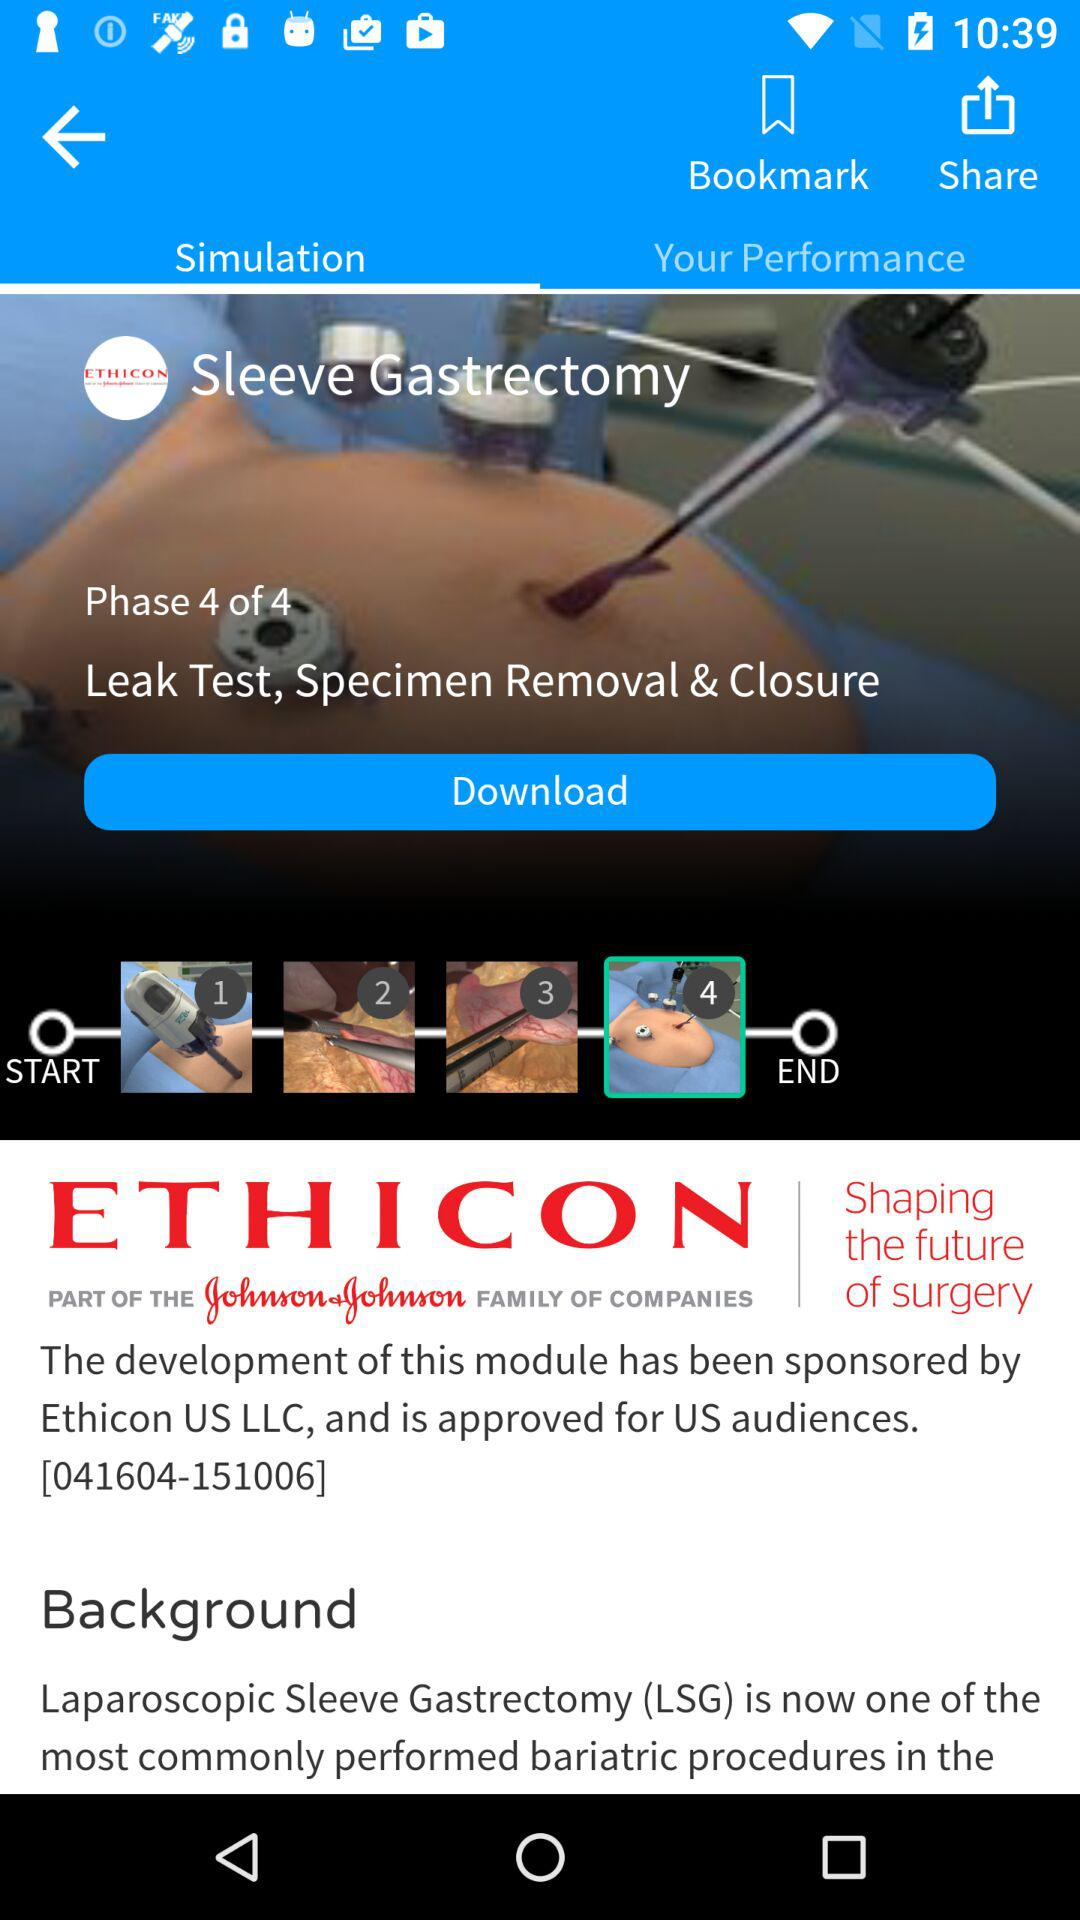What's the 4th Phase? The 4th Phase is "Leak Test, Specimen Removal & Closure". 